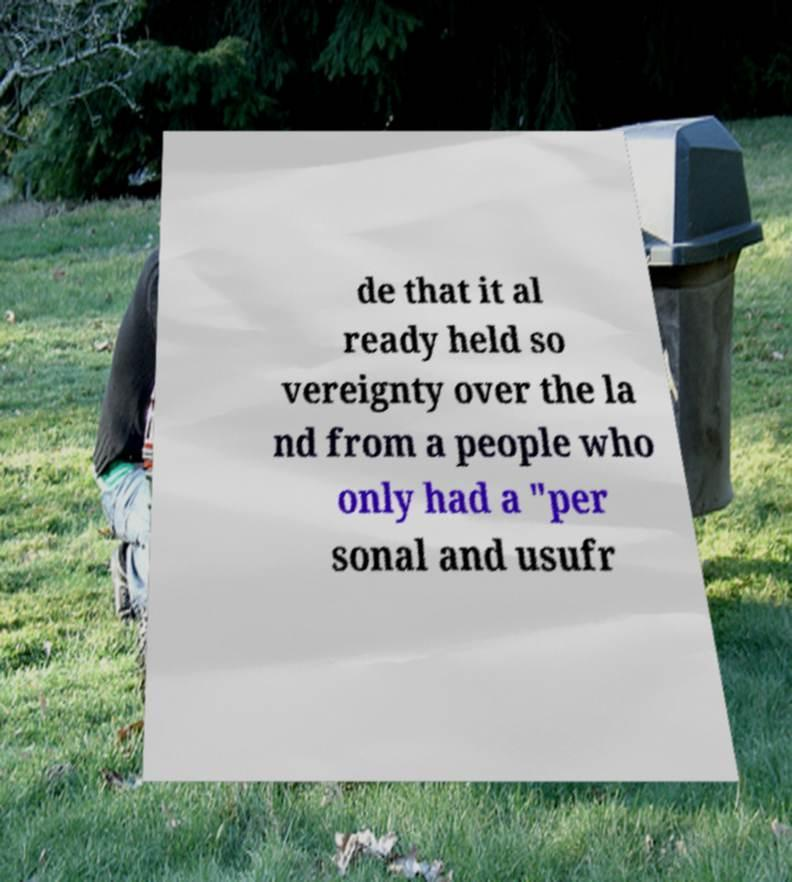Could you extract and type out the text from this image? de that it al ready held so vereignty over the la nd from a people who only had a "per sonal and usufr 